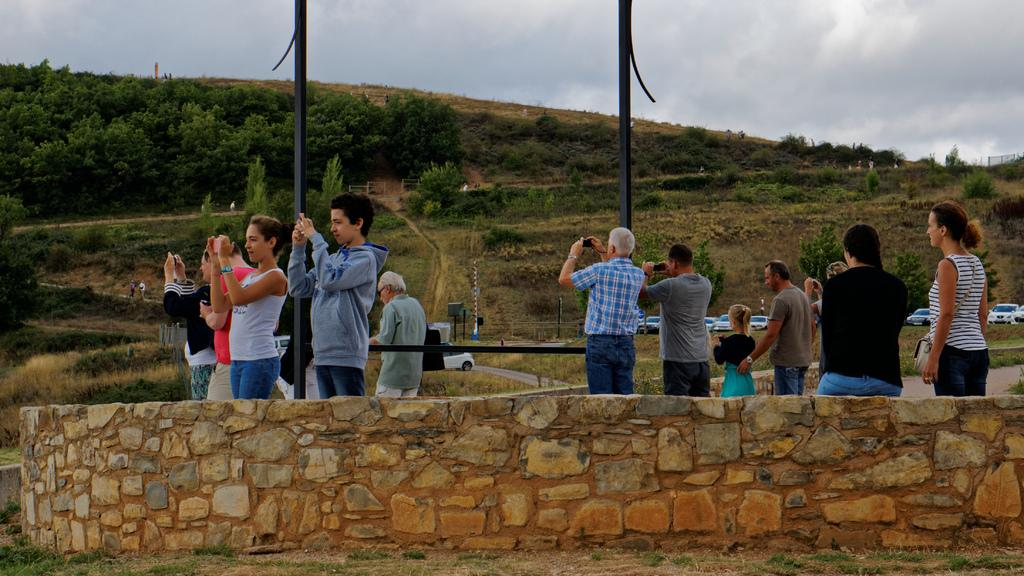What are the people in the image doing? There are people taking pictures in the image. What natural feature can be seen in the background of the image? Mountains are visible in the image. What structures can be seen in the image? There are poles and a rock wall in the image. What type of vehicles are present in the image? Cars are present in the image. Can you describe the crowd in the image? There are many people in the distance. How does the swing move in the image? There is no swing present in the image. Can you describe the cough of the expert in the image? There is no expert or coughing in the image. 